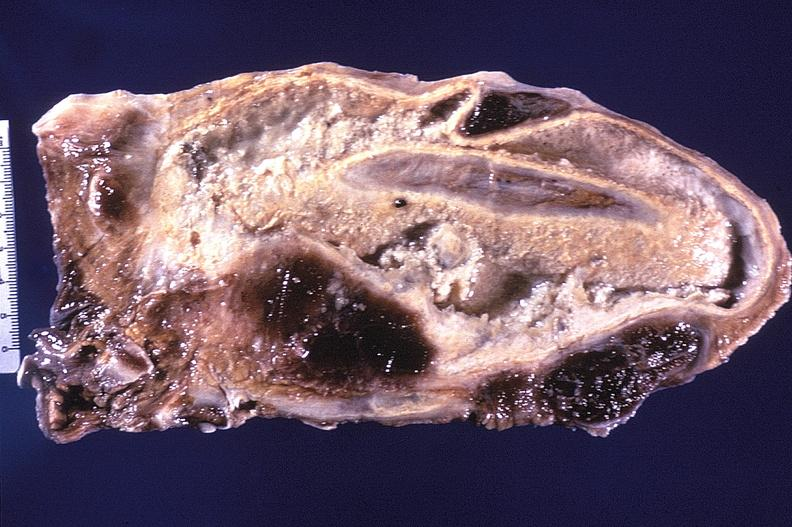what is present?
Answer the question using a single word or phrase. Respiratory 